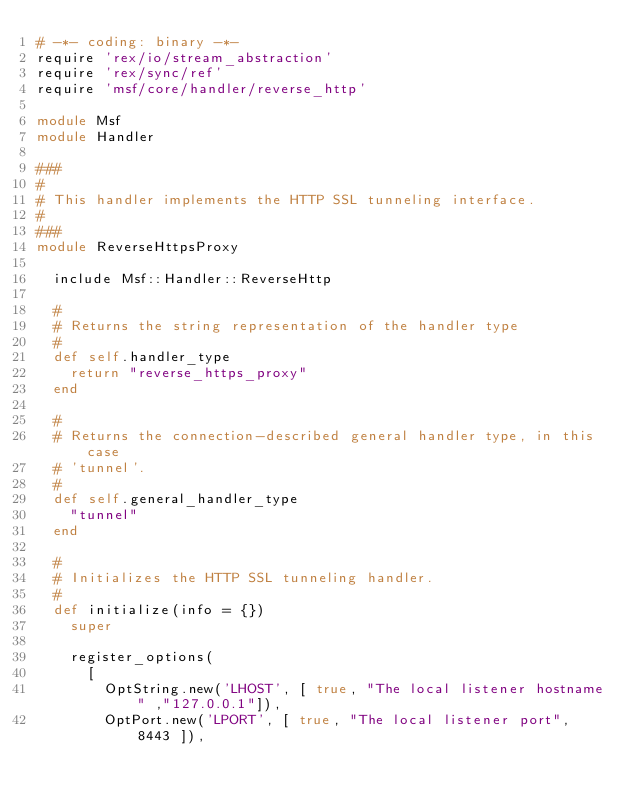Convert code to text. <code><loc_0><loc_0><loc_500><loc_500><_Ruby_># -*- coding: binary -*-
require 'rex/io/stream_abstraction'
require 'rex/sync/ref'
require 'msf/core/handler/reverse_http'

module Msf
module Handler

###
#
# This handler implements the HTTP SSL tunneling interface.
#
###
module ReverseHttpsProxy

  include Msf::Handler::ReverseHttp

  #
  # Returns the string representation of the handler type
  #
  def self.handler_type
    return "reverse_https_proxy"
  end

  #
  # Returns the connection-described general handler type, in this case
  # 'tunnel'.
  #
  def self.general_handler_type
    "tunnel"
  end

  #
  # Initializes the HTTP SSL tunneling handler.
  #
  def initialize(info = {})
    super

    register_options(
      [
        OptString.new('LHOST', [ true, "The local listener hostname" ,"127.0.0.1"]),
        OptPort.new('LPORT', [ true, "The local listener port", 8443 ]),</code> 